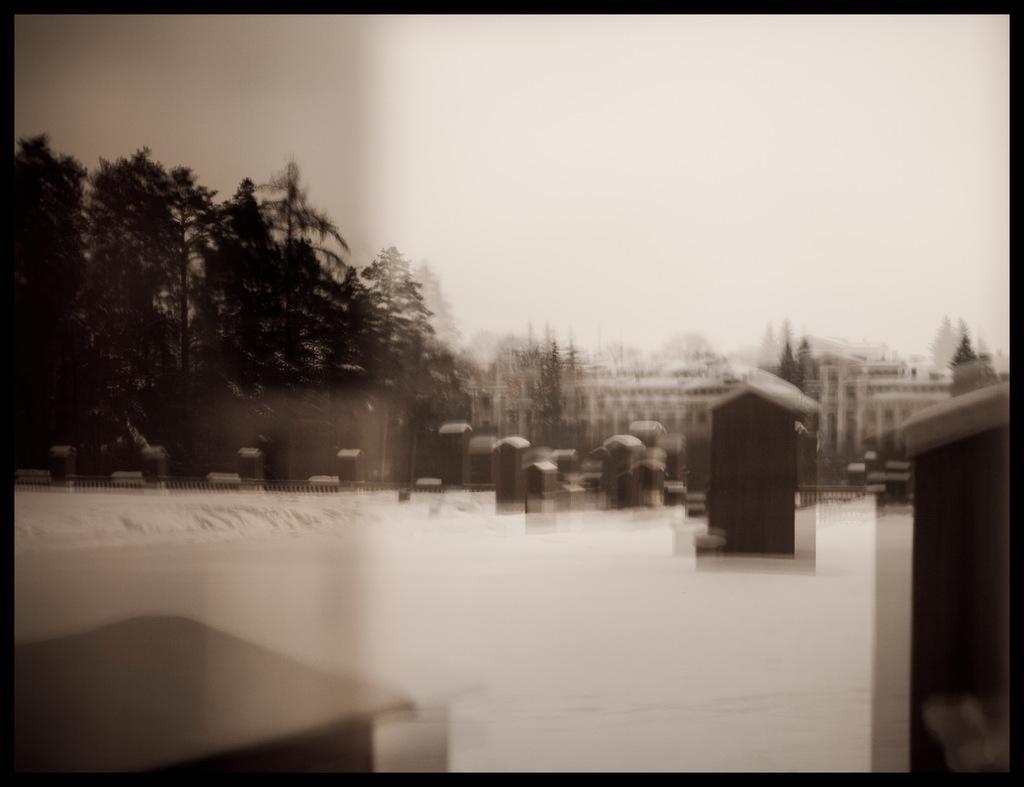In one or two sentences, can you explain what this image depicts? This is a blur black and white image where we can see there are trees and buildings. 